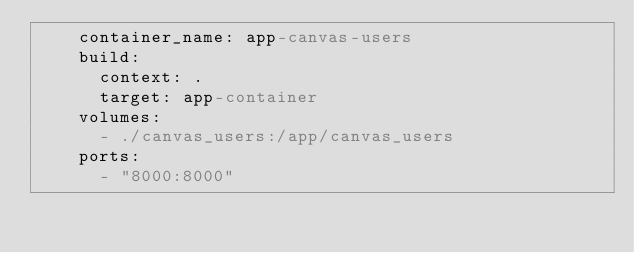Convert code to text. <code><loc_0><loc_0><loc_500><loc_500><_YAML_>    container_name: app-canvas-users
    build:
      context: .
      target: app-container
    volumes:
      - ./canvas_users:/app/canvas_users
    ports:
      - "8000:8000"
</code> 